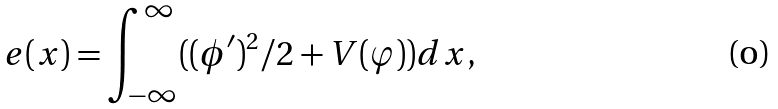Convert formula to latex. <formula><loc_0><loc_0><loc_500><loc_500>e ( x ) = \int _ { - \infty } ^ { \infty } ( ( \phi ^ { \prime } ) ^ { 2 } / 2 + V ( \varphi ) ) d x ,</formula> 